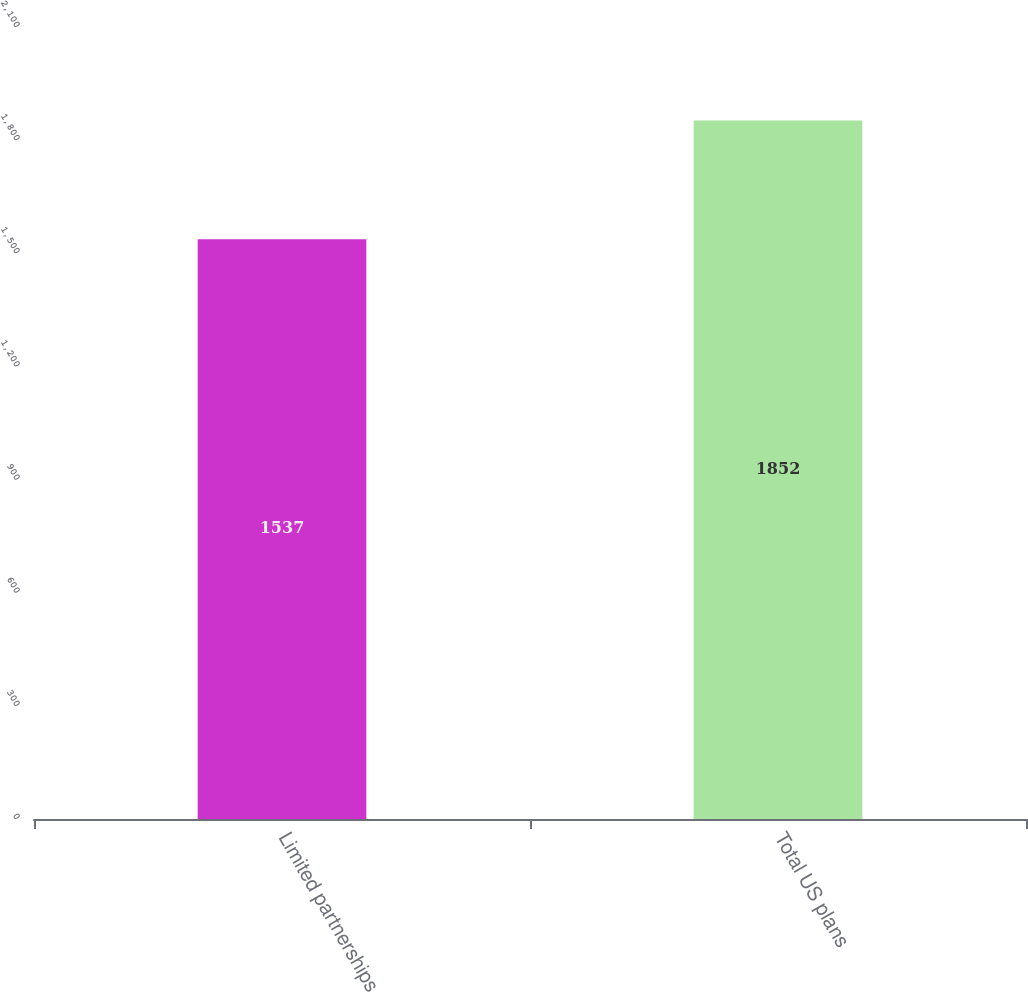<chart> <loc_0><loc_0><loc_500><loc_500><bar_chart><fcel>Limited partnerships<fcel>Total US plans<nl><fcel>1537<fcel>1852<nl></chart> 